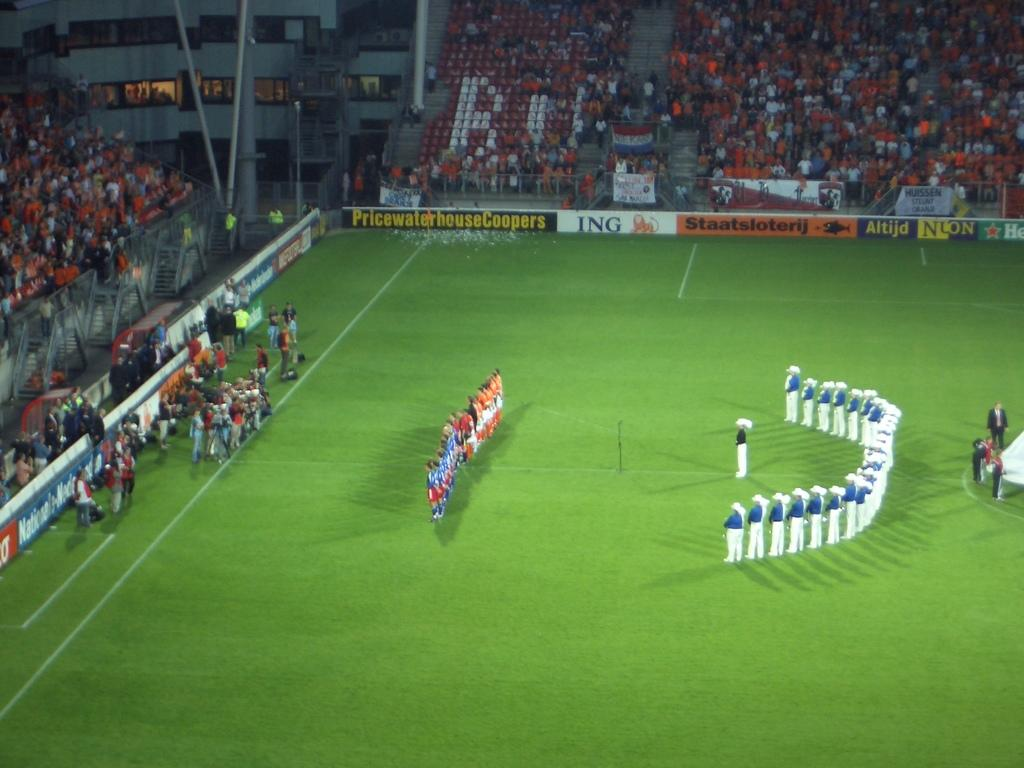<image>
Render a clear and concise summary of the photo. The teams are lined up on the field bordered by a sign for Pricewaterhouse Coopers. 